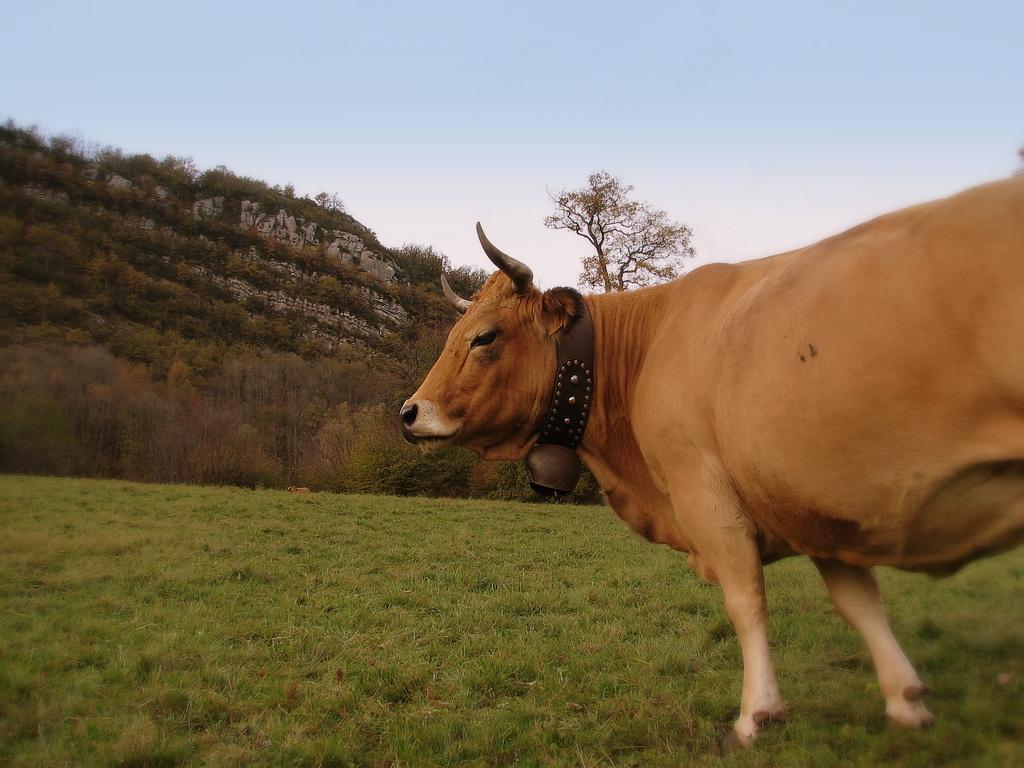Please provide a concise description of this image. In this picture we can see a bull on the right side, there is a bell present on bull's neck, at the bottom there is grass, in the background we can see some plants and a tree, we can see the sky at the top of the picture. 